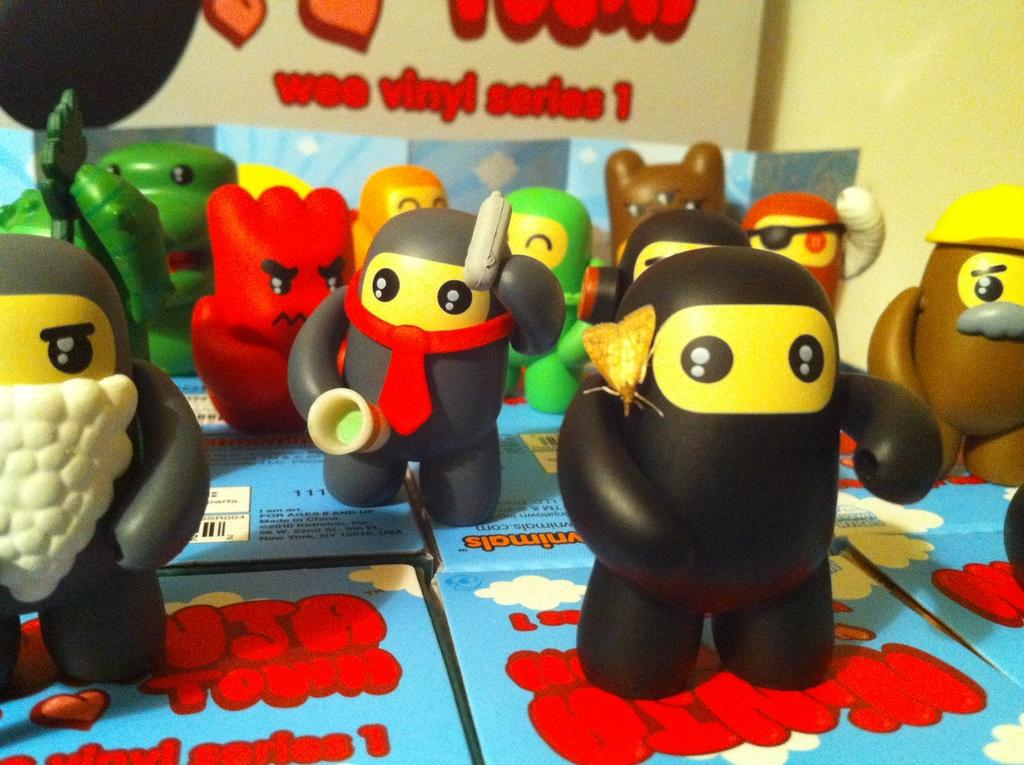What objects are located at the bottom of the image? There are boxes on the bottom of the image. What type of items can be seen in the image besides the boxes? There are colorful baby toys in the image. What is written or depicted on the wall in the image? There is a wall with some text in the image. What type of voice can be heard coming from the baby toys in the image? There is no indication in the image that the baby toys make any sounds or have a voice. 